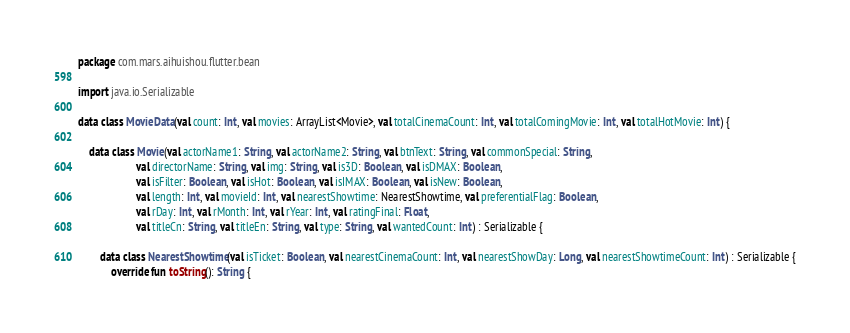Convert code to text. <code><loc_0><loc_0><loc_500><loc_500><_Kotlin_>package com.mars.aihuishou.flutter.bean

import java.io.Serializable

data class MovieData(val count: Int, val movies: ArrayList<Movie>, val totalCinemaCount: Int, val totalComingMovie: Int, val totalHotMovie: Int) {

    data class Movie(val actorName1: String, val actorName2: String, val btnText: String, val commonSpecial: String,
                     val directorName: String, val img: String, val is3D: Boolean, val isDMAX: Boolean,
                     val isFilter: Boolean, val isHot: Boolean, val isIMAX: Boolean, val isNew: Boolean,
                     val length: Int, val movieId: Int, val nearestShowtime: NearestShowtime, val preferentialFlag: Boolean,
                     val rDay: Int, val rMonth: Int, val rYear: Int, val ratingFinal: Float,
                     val titleCn: String, val titleEn: String, val type: String, val wantedCount: Int) : Serializable {

        data class NearestShowtime(val isTicket: Boolean, val nearestCinemaCount: Int, val nearestShowDay: Long, val nearestShowtimeCount: Int) : Serializable {
            override fun toString(): String {</code> 